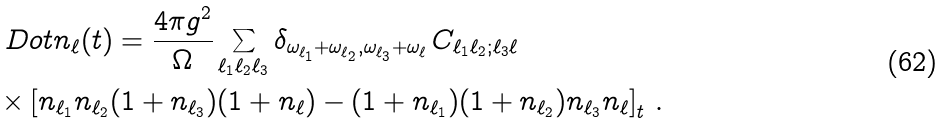<formula> <loc_0><loc_0><loc_500><loc_500>& \ D o t { n } _ { \ell } ( t ) = \frac { 4 \pi g ^ { 2 } } { \Omega } \sum _ { \ell _ { 1 } \ell _ { 2 } \ell _ { 3 } } \delta _ { \omega _ { \ell _ { 1 } } + \omega _ { \ell _ { 2 } } , \omega _ { \ell _ { 3 } } + \omega _ { \ell } } \, C _ { \ell _ { 1 } \ell _ { 2 } ; \ell _ { 3 } \ell } \\ & \times \left [ n _ { \ell _ { 1 } } n _ { \ell _ { 2 } } ( 1 + n _ { \ell _ { 3 } } ) ( 1 + n _ { \ell } ) - ( 1 + n _ { \ell _ { 1 } } ) ( 1 + n _ { \ell _ { 2 } } ) n _ { \ell _ { 3 } } n _ { \ell } \right ] _ { t } \, .</formula> 